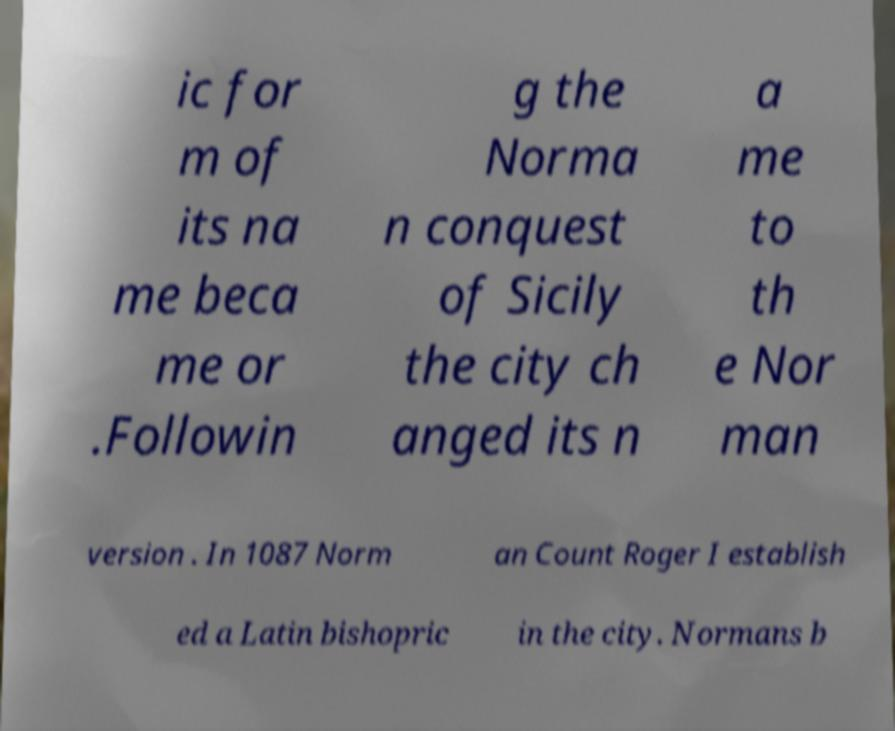Could you extract and type out the text from this image? ic for m of its na me beca me or .Followin g the Norma n conquest of Sicily the city ch anged its n a me to th e Nor man version . In 1087 Norm an Count Roger I establish ed a Latin bishopric in the city. Normans b 